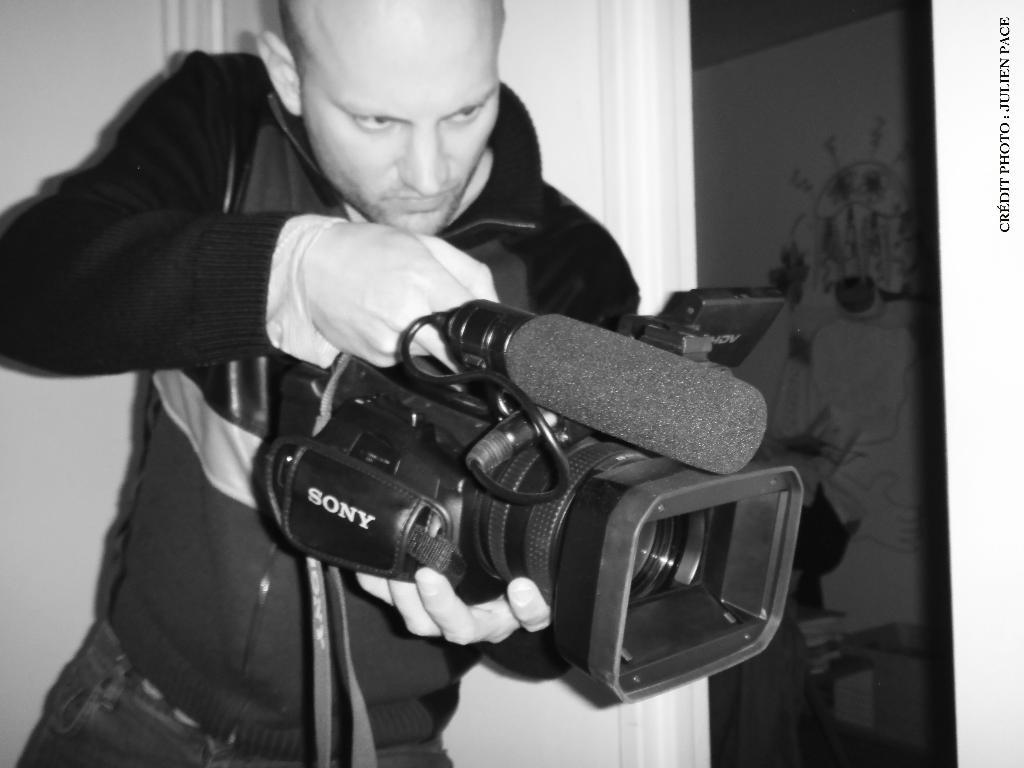What is the man in the image holding? The man is holding a camera. What is attached to the camera in the image? A microphone is attached to the camera. What is the man's posture in the image? The man is standing. What can be seen in the background of the image? There is a wall in the background of the image. Reasoning: Let's think step by step by step in order to produce the conversation. We start by identifying the main subject in the image, which is the man. Then, we describe the objects he is holding and interacting with, such as the camera and microphone. We also mention his posture and what can be seen in the background. Each question is designed to elicit a specific detail about the image that is known from the provided facts. Absurd Question/Answer: What type of pipe can be seen in the image? There is no pipe present in the image. What is the man's behavior in the image? The provided facts do not give information about the man's behavior, only his posture and what he is holding. What type of pipe can be seen in the image? There is no pipe present in the image. What is the man's behavior in the image? The provided facts do not give information about the man's behavior, only his posture and what he is holding. 